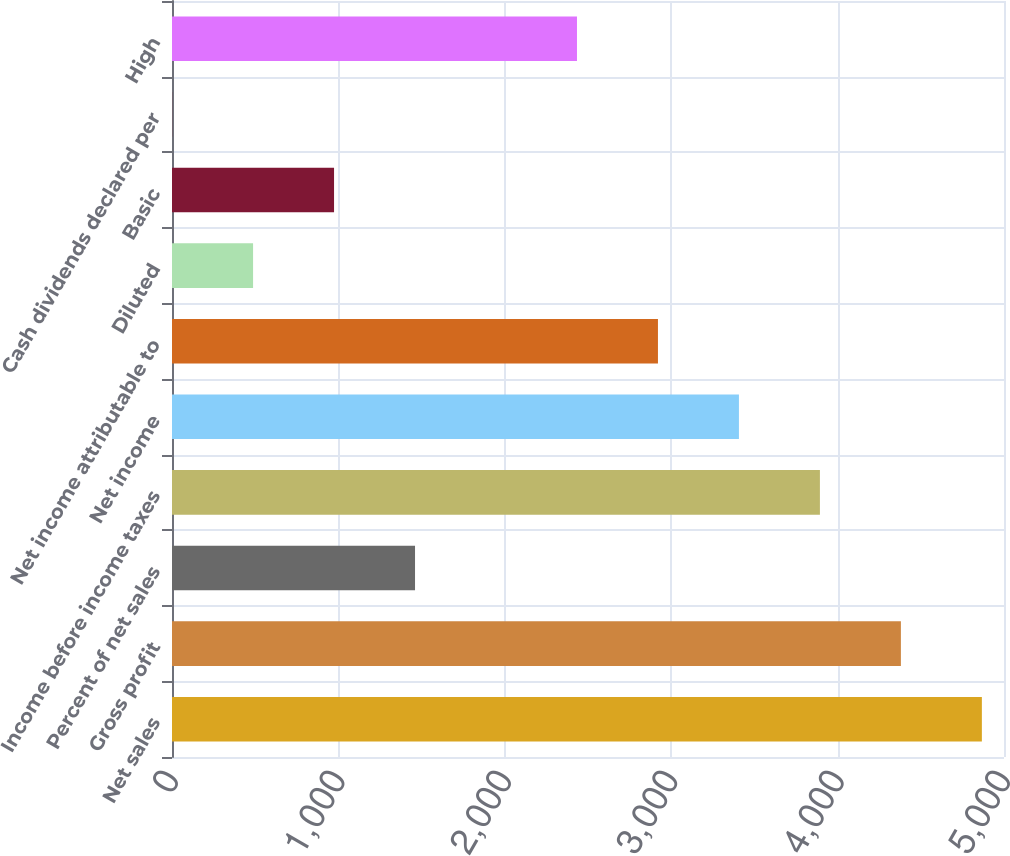Convert chart to OTSL. <chart><loc_0><loc_0><loc_500><loc_500><bar_chart><fcel>Net sales<fcel>Gross profit<fcel>Percent of net sales<fcel>Income before income taxes<fcel>Net income<fcel>Net income attributable to<fcel>Diluted<fcel>Basic<fcel>Cash dividends declared per<fcel>High<nl><fcel>4867<fcel>4380.33<fcel>1460.49<fcel>3893.69<fcel>3407.05<fcel>2920.41<fcel>487.21<fcel>973.85<fcel>0.57<fcel>2433.77<nl></chart> 